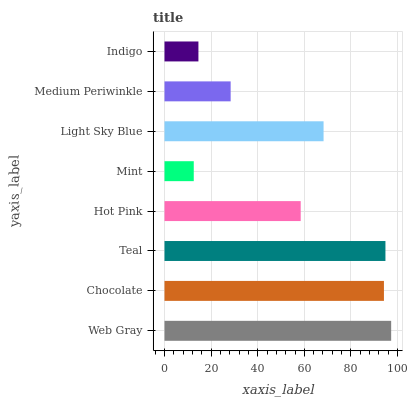Is Mint the minimum?
Answer yes or no. Yes. Is Web Gray the maximum?
Answer yes or no. Yes. Is Chocolate the minimum?
Answer yes or no. No. Is Chocolate the maximum?
Answer yes or no. No. Is Web Gray greater than Chocolate?
Answer yes or no. Yes. Is Chocolate less than Web Gray?
Answer yes or no. Yes. Is Chocolate greater than Web Gray?
Answer yes or no. No. Is Web Gray less than Chocolate?
Answer yes or no. No. Is Light Sky Blue the high median?
Answer yes or no. Yes. Is Hot Pink the low median?
Answer yes or no. Yes. Is Chocolate the high median?
Answer yes or no. No. Is Light Sky Blue the low median?
Answer yes or no. No. 